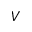Convert formula to latex. <formula><loc_0><loc_0><loc_500><loc_500>V</formula> 